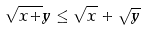<formula> <loc_0><loc_0><loc_500><loc_500>\sqrt { x + } y \leq \sqrt { x } + \sqrt { y }</formula> 